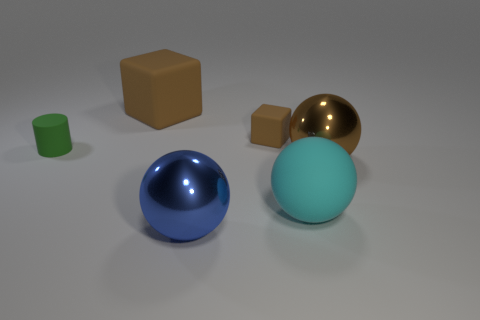Can you describe the lighting and shadows visible in the image? The image features soft, diffuse lighting, which creates gentle shadows under each object. The shadows help emphasize the spatial relationships and the three-dimensional form of the objects on a flat surface. 